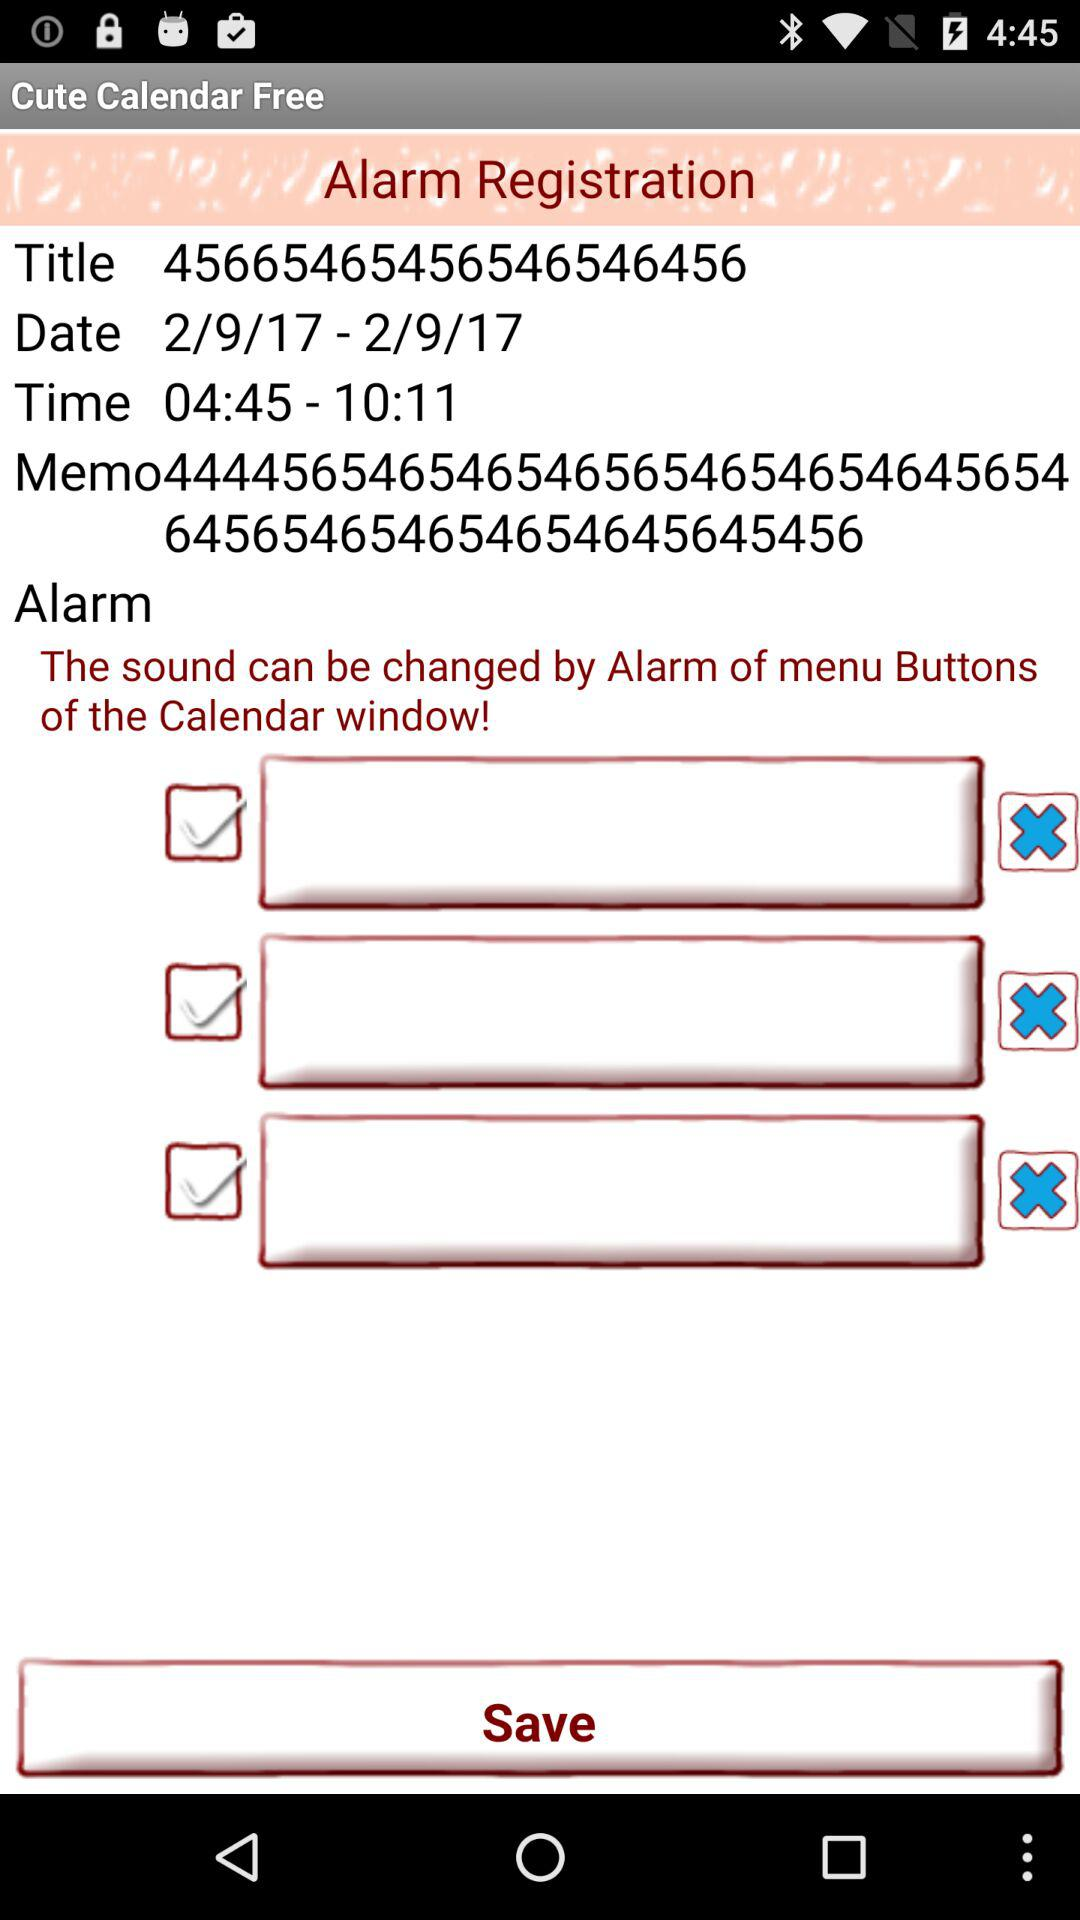What is the date for the alarm registration? The date for the alarm registration is February 9, 2017. 